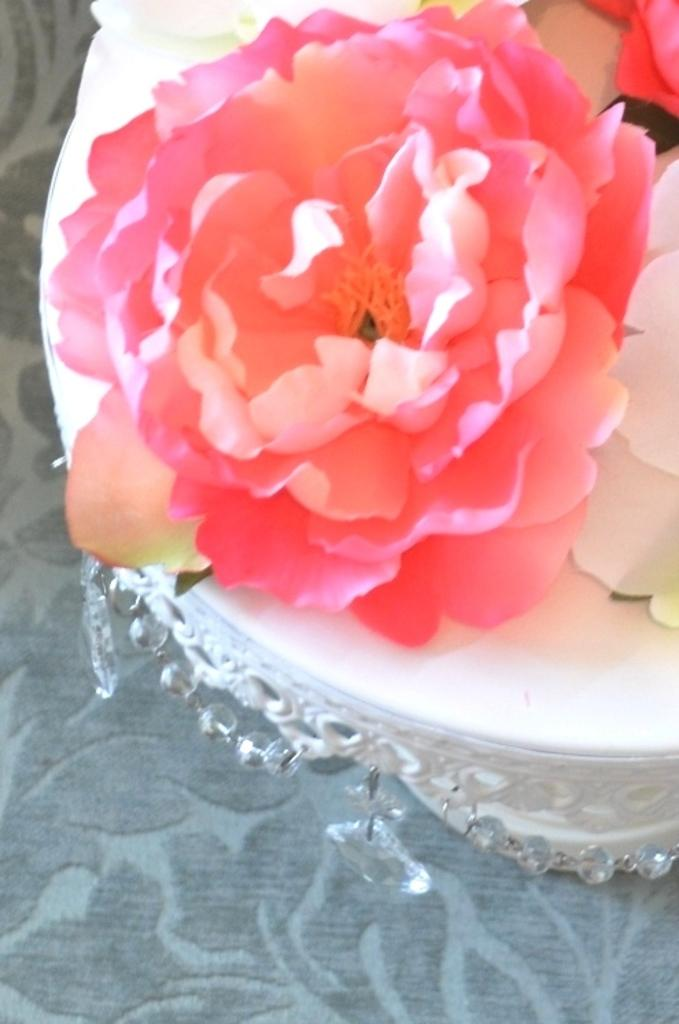What type of flower is in the image? There is a reddish flower in the image. What is the color of the surface the flower is placed on? The flower is placed on a white surface. What else can be seen in the image besides the flower? There are decorative items in the image. How much profit does the flower generate in the image? The image does not depict any financial transactions or profits, so it is not possible to determine the profit generated by the flower. 